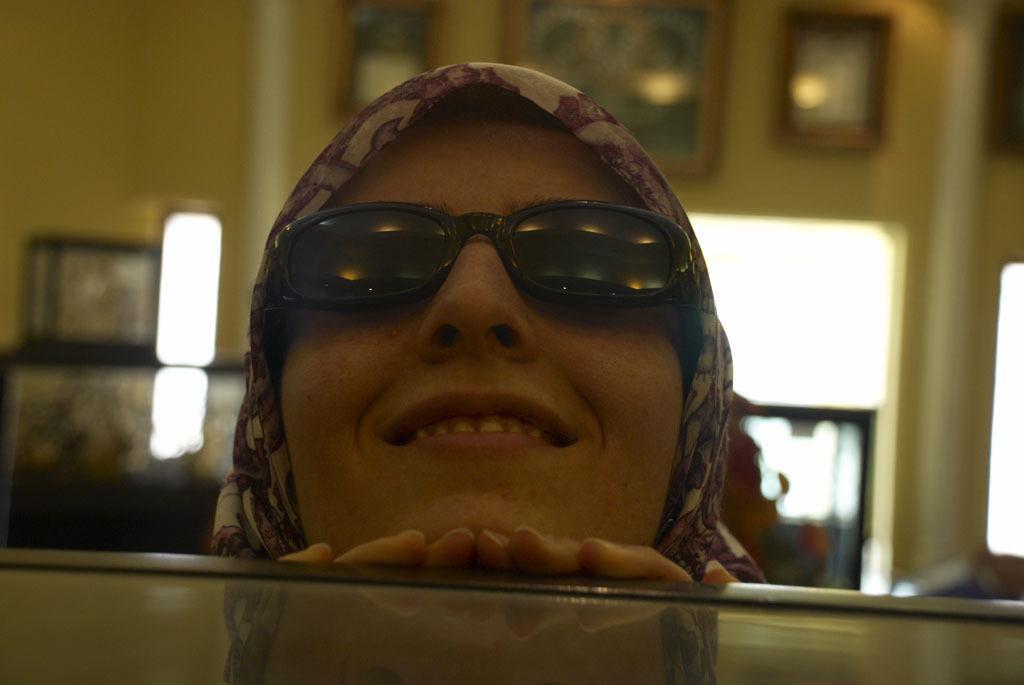Please provide a concise description of this image. At the bottom of the image we can see one glass object. In the center of the image we can see one woman is smiling, which we can see on her face and she is wearing glasses. In the background there is a wall, lights, photo frames and a few other objects. 